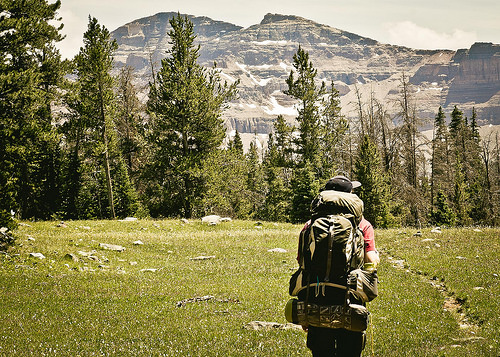<image>
Is the man in front of the mountain? Yes. The man is positioned in front of the mountain, appearing closer to the camera viewpoint. 